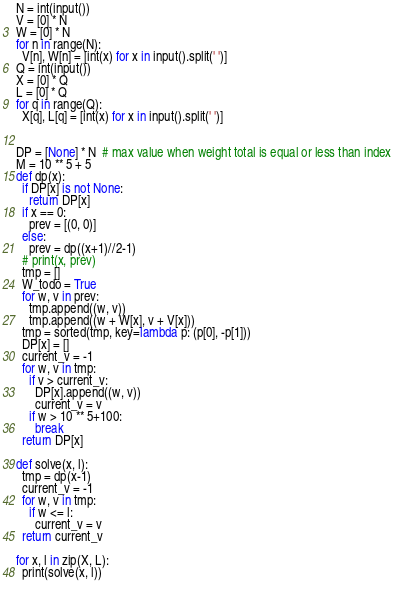<code> <loc_0><loc_0><loc_500><loc_500><_Python_>N = int(input())
V = [0] * N
W = [0] * N
for n in range(N):
  V[n], W[n] = [int(x) for x in input().split(' ')]
Q = int(input())
X = [0] * Q
L = [0] * Q
for q in range(Q):
  X[q], L[q] = [int(x) for x in input().split(' ')]

  
DP = [None] * N  # max value when weight total is equal or less than index
M = 10 ** 5 + 5
def dp(x):
  if DP[x] is not None:
    return DP[x]
  if x == 0:
    prev = [(0, 0)]
  else:
    prev = dp((x+1)//2-1)
  # print(x, prev)
  tmp = []
  W_todo = True
  for w, v in prev:
    tmp.append((w, v))
    tmp.append((w + W[x], v + V[x]))
  tmp = sorted(tmp, key=lambda p: (p[0], -p[1]))
  DP[x] = []
  current_v = -1
  for w, v in tmp:
    if v > current_v:
      DP[x].append((w, v))
      current_v = v
    if w > 10 ** 5+100:
      break
  return DP[x]

def solve(x, l):
  tmp = dp(x-1)
  current_v = -1
  for w, v in tmp:
    if w <= l:
      current_v = v
  return current_v

for x, l in zip(X, L):
  print(solve(x, l))
  
</code> 